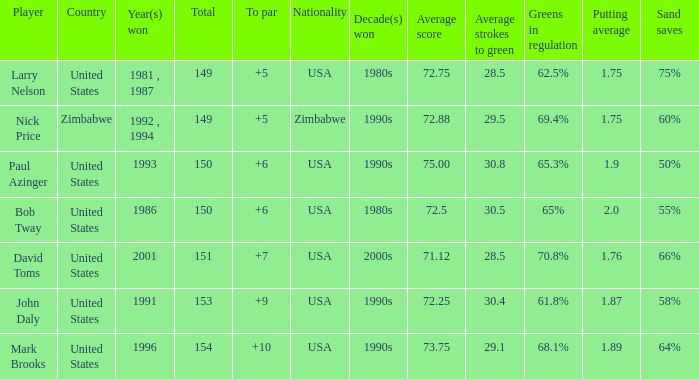What is Zimbabwe's total with a to par higher than 5? None. 